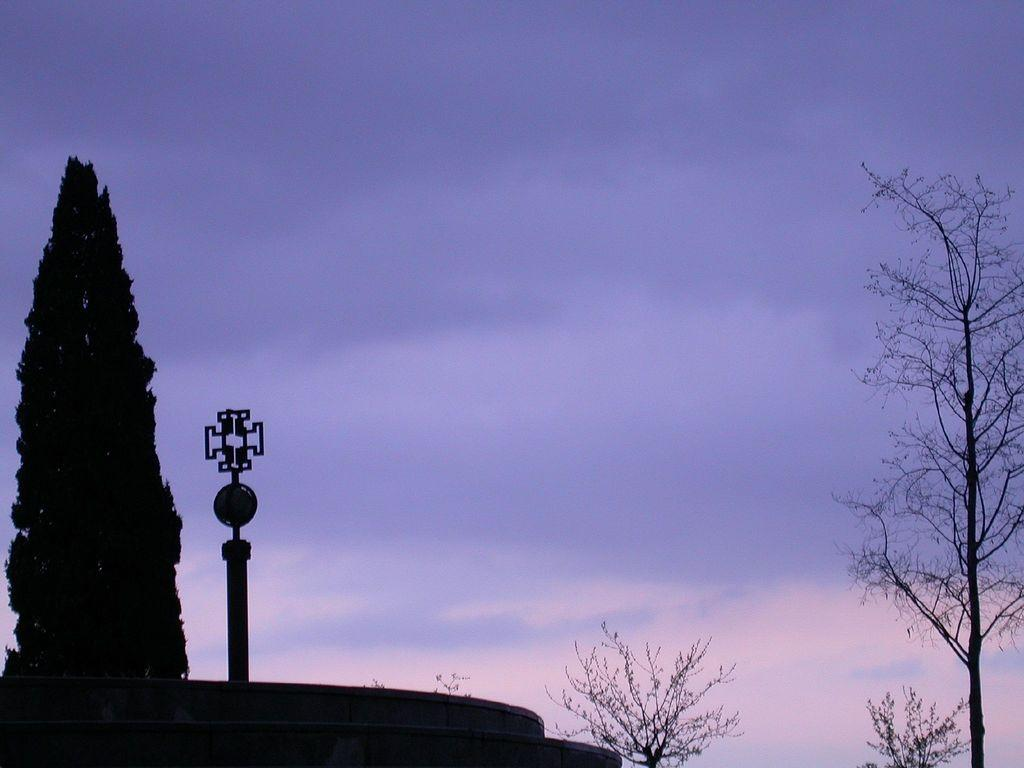What type of vegetation can be seen in the image? There are trees in the image. What object is present in the image besides the trees? There is a pole in the image. What can be seen in the background of the image? The sky is visible in the background of the image. What is the condition of the sky in the image? Clouds are present in the sky. How does the tree help the spy in the image? There is no spy present in the image, and therefore no help can be provided by the tree. What type of learning is taking place in the image? There is no learning activity depicted in the image. 